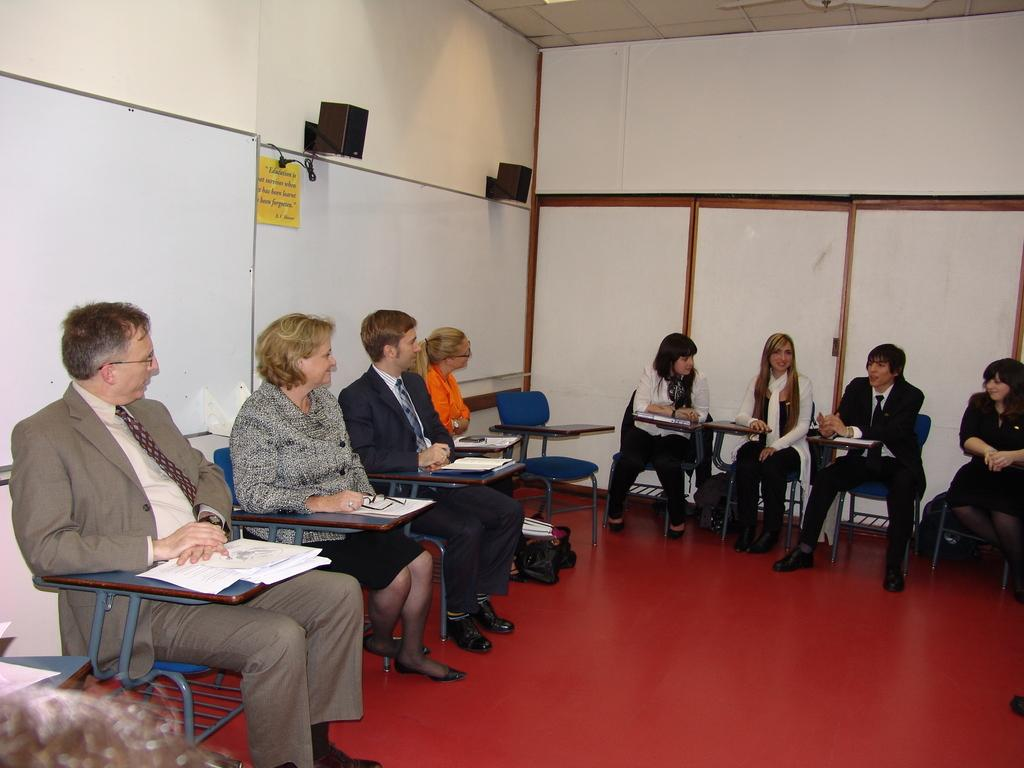What are the people in the image doing? The people in the image are sitting on chairs. What objects can be seen on the table or in the hands of the people? Papers and bags are visible in the image. What type of structure can be seen in the background? Walls are visible in the image. What type of twig is being used to hammer nails into the wall in the image? There is no twig or hammer present in the image; the people are simply sitting on chairs with papers and bags visible. 